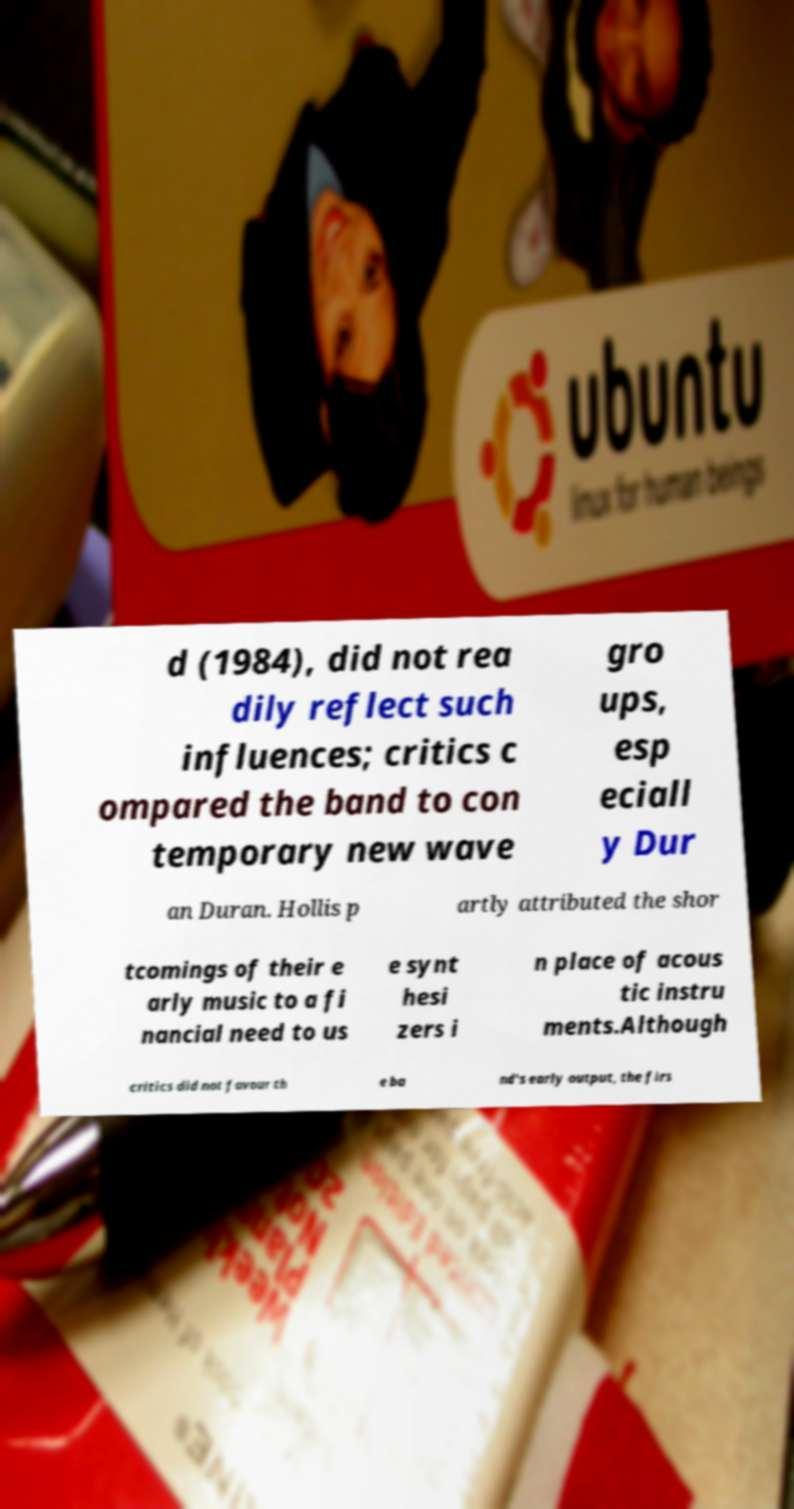Can you accurately transcribe the text from the provided image for me? d (1984), did not rea dily reflect such influences; critics c ompared the band to con temporary new wave gro ups, esp eciall y Dur an Duran. Hollis p artly attributed the shor tcomings of their e arly music to a fi nancial need to us e synt hesi zers i n place of acous tic instru ments.Although critics did not favour th e ba nd's early output, the firs 